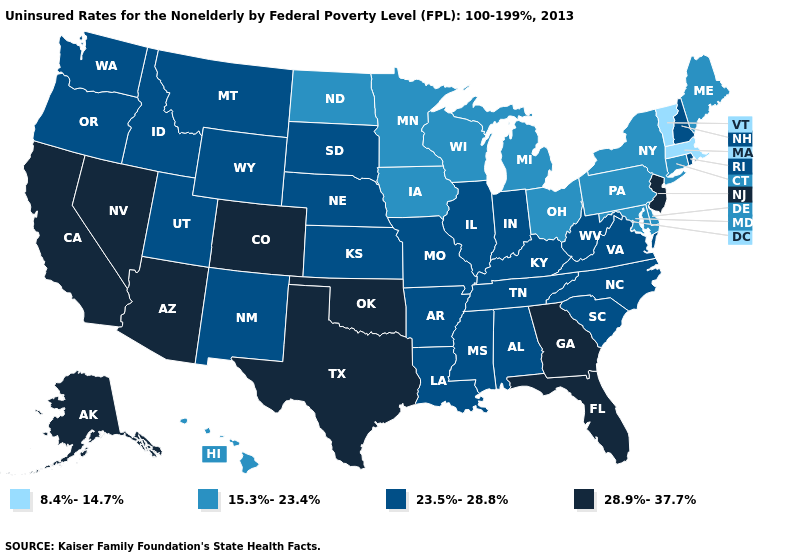What is the value of California?
Be succinct. 28.9%-37.7%. Does New York have the same value as Oregon?
Keep it brief. No. What is the lowest value in the USA?
Give a very brief answer. 8.4%-14.7%. Name the states that have a value in the range 28.9%-37.7%?
Give a very brief answer. Alaska, Arizona, California, Colorado, Florida, Georgia, Nevada, New Jersey, Oklahoma, Texas. Among the states that border Indiana , which have the lowest value?
Give a very brief answer. Michigan, Ohio. What is the value of Hawaii?
Concise answer only. 15.3%-23.4%. Name the states that have a value in the range 28.9%-37.7%?
Be succinct. Alaska, Arizona, California, Colorado, Florida, Georgia, Nevada, New Jersey, Oklahoma, Texas. Does Iowa have the highest value in the MidWest?
Answer briefly. No. Name the states that have a value in the range 15.3%-23.4%?
Be succinct. Connecticut, Delaware, Hawaii, Iowa, Maine, Maryland, Michigan, Minnesota, New York, North Dakota, Ohio, Pennsylvania, Wisconsin. What is the lowest value in states that border Mississippi?
Answer briefly. 23.5%-28.8%. Does Massachusetts have the lowest value in the USA?
Write a very short answer. Yes. Name the states that have a value in the range 8.4%-14.7%?
Answer briefly. Massachusetts, Vermont. What is the value of West Virginia?
Answer briefly. 23.5%-28.8%. Name the states that have a value in the range 23.5%-28.8%?
Write a very short answer. Alabama, Arkansas, Idaho, Illinois, Indiana, Kansas, Kentucky, Louisiana, Mississippi, Missouri, Montana, Nebraska, New Hampshire, New Mexico, North Carolina, Oregon, Rhode Island, South Carolina, South Dakota, Tennessee, Utah, Virginia, Washington, West Virginia, Wyoming. 